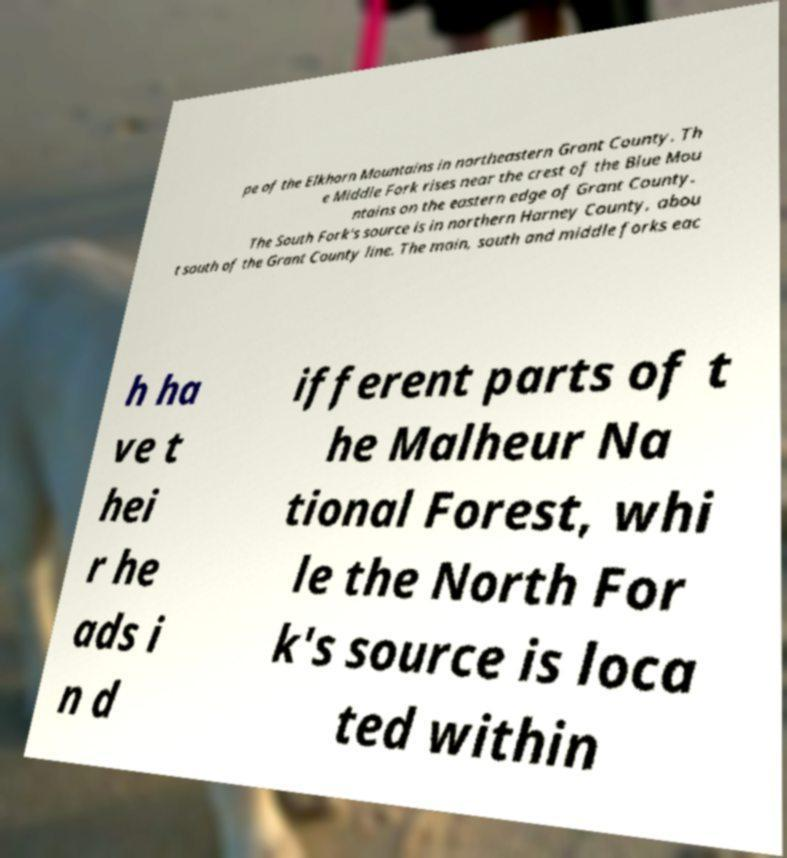I need the written content from this picture converted into text. Can you do that? pe of the Elkhorn Mountains in northeastern Grant County. Th e Middle Fork rises near the crest of the Blue Mou ntains on the eastern edge of Grant County. The South Fork's source is in northern Harney County, abou t south of the Grant County line. The main, south and middle forks eac h ha ve t hei r he ads i n d ifferent parts of t he Malheur Na tional Forest, whi le the North For k's source is loca ted within 